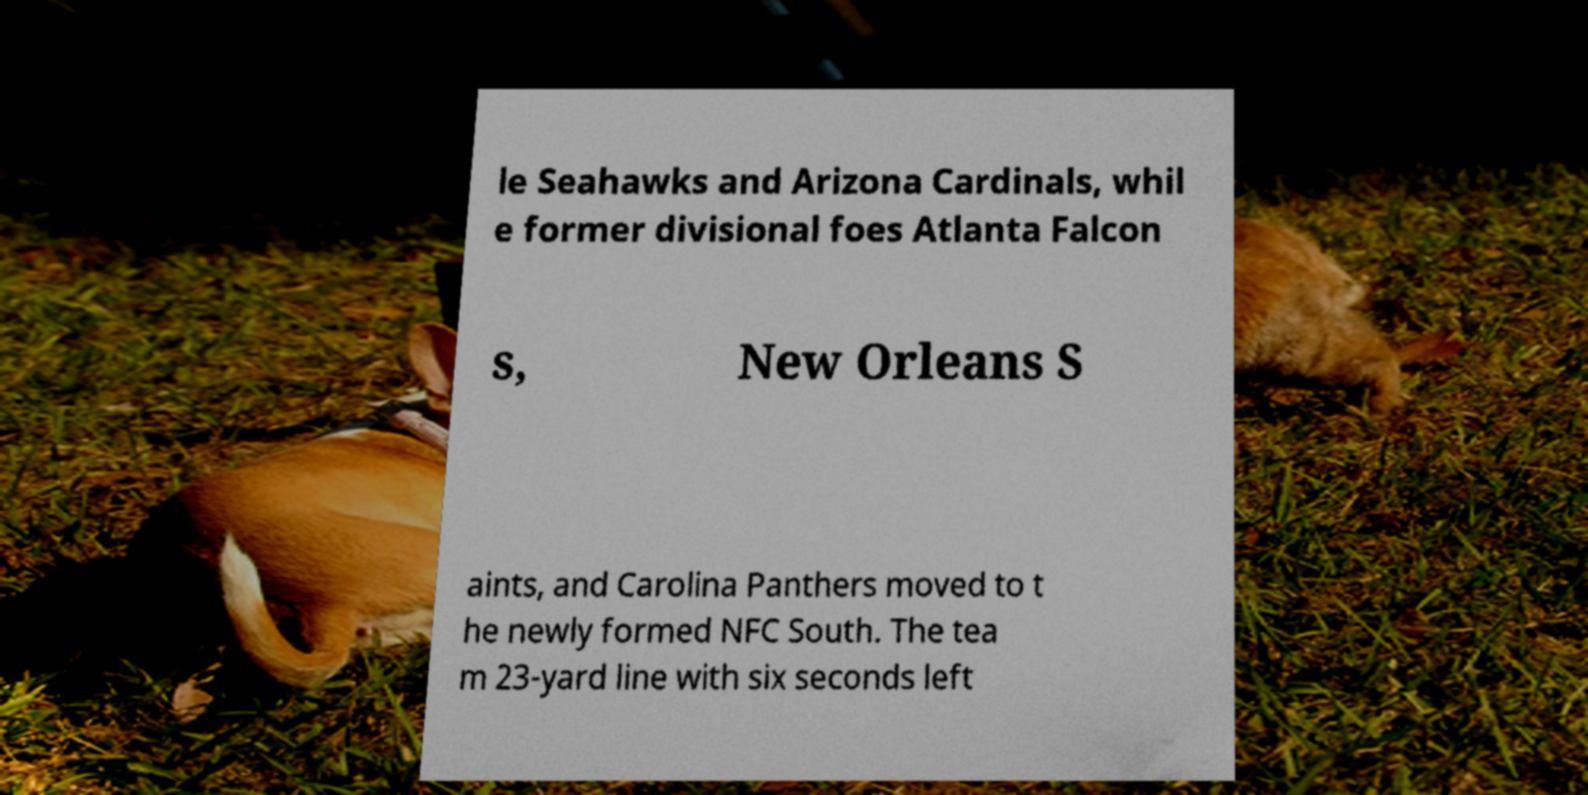Could you extract and type out the text from this image? le Seahawks and Arizona Cardinals, whil e former divisional foes Atlanta Falcon s, New Orleans S aints, and Carolina Panthers moved to t he newly formed NFC South. The tea m 23-yard line with six seconds left 